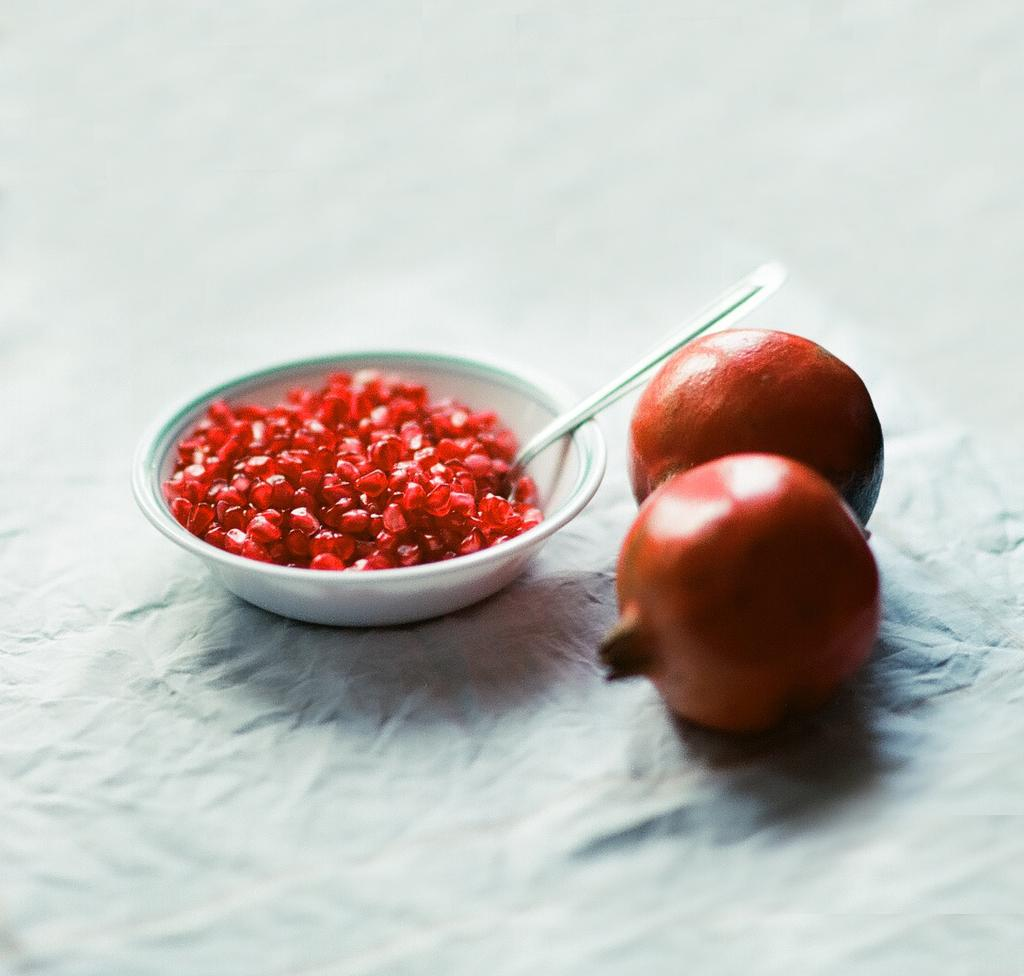What type of fruit is featured in the image? There are two pomegranates in the image. What is the result of cutting open the pomegranates? There is a bowl of pomegranate seeds in the image. What utensil is present in the image? A spoon is present in the image. What color is the surface in the background of the image? The surface in the background of the image is white. What type of rail is visible in the image? There is no rail present in the image. What is the purpose of the boot in the image? There is no boot present in the image. 